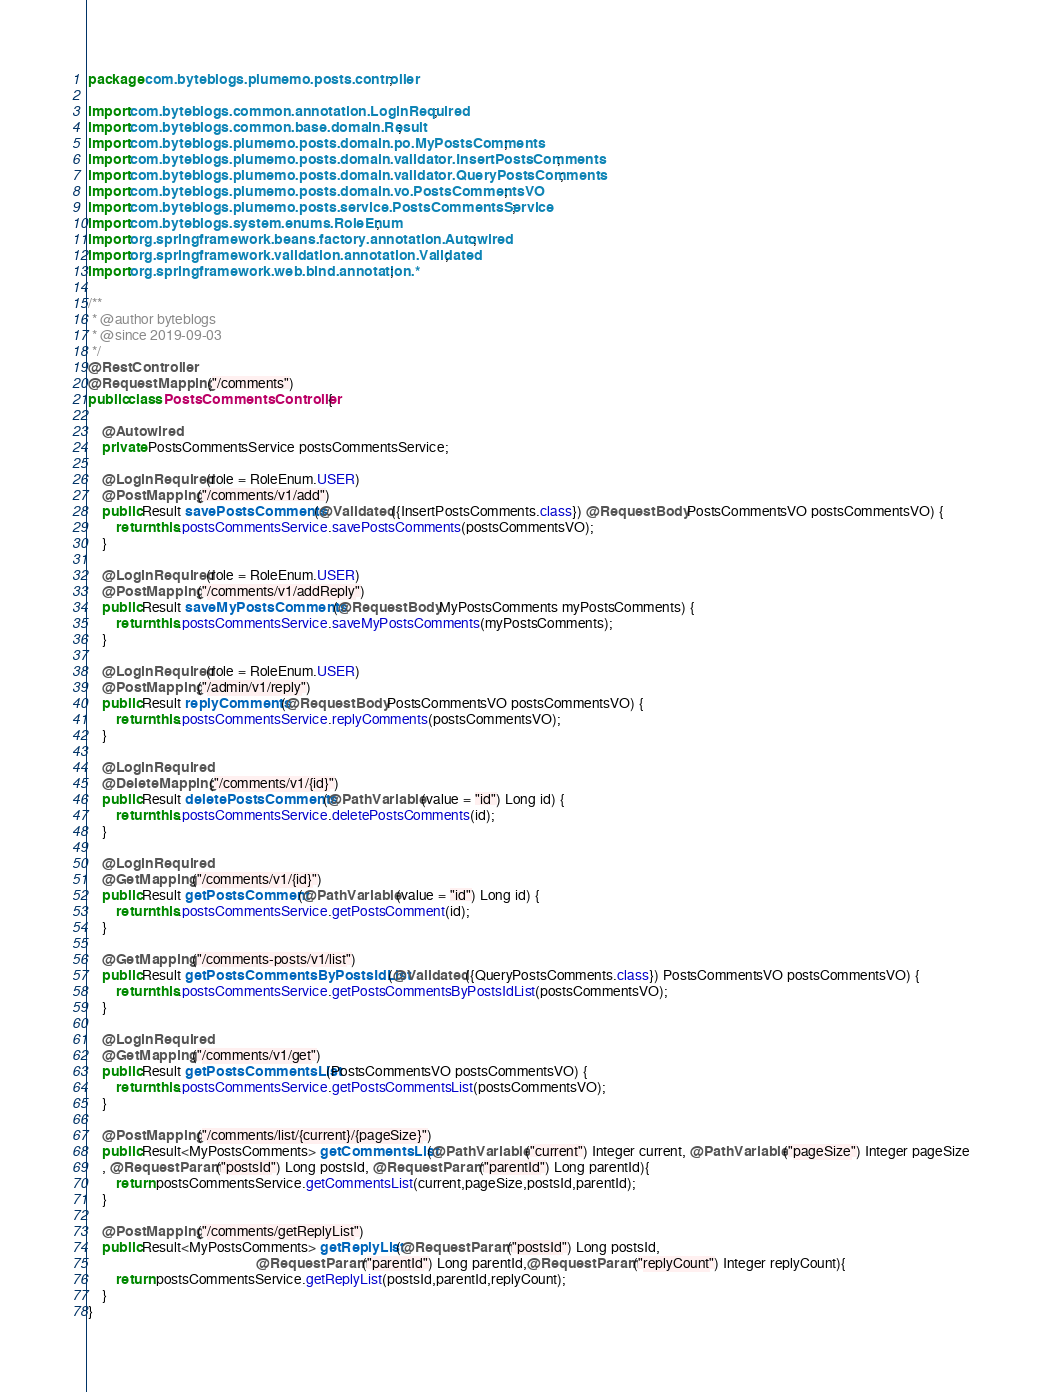Convert code to text. <code><loc_0><loc_0><loc_500><loc_500><_Java_>package com.byteblogs.plumemo.posts.controller;

import com.byteblogs.common.annotation.LoginRequired;
import com.byteblogs.common.base.domain.Result;
import com.byteblogs.plumemo.posts.domain.po.MyPostsComments;
import com.byteblogs.plumemo.posts.domain.validator.InsertPostsComments;
import com.byteblogs.plumemo.posts.domain.validator.QueryPostsComments;
import com.byteblogs.plumemo.posts.domain.vo.PostsCommentsVO;
import com.byteblogs.plumemo.posts.service.PostsCommentsService;
import com.byteblogs.system.enums.RoleEnum;
import org.springframework.beans.factory.annotation.Autowired;
import org.springframework.validation.annotation.Validated;
import org.springframework.web.bind.annotation.*;

/**
 * @author byteblogs
 * @since 2019-09-03
 */
@RestController
@RequestMapping("/comments")
public class PostsCommentsController {

    @Autowired
    private PostsCommentsService postsCommentsService;

    @LoginRequired(role = RoleEnum.USER)
    @PostMapping("/comments/v1/add")
    public Result savePostsComments(@Validated({InsertPostsComments.class}) @RequestBody PostsCommentsVO postsCommentsVO) {
        return this.postsCommentsService.savePostsComments(postsCommentsVO);
    }

    @LoginRequired(role = RoleEnum.USER)
    @PostMapping("/comments/v1/addReply")
    public Result saveMyPostsComments(@RequestBody MyPostsComments myPostsComments) {
        return this.postsCommentsService.saveMyPostsComments(myPostsComments);
    }

    @LoginRequired(role = RoleEnum.USER)
    @PostMapping("/admin/v1/reply")
    public Result replyComments(@RequestBody PostsCommentsVO postsCommentsVO) {
        return this.postsCommentsService.replyComments(postsCommentsVO);
    }

    @LoginRequired
    @DeleteMapping("/comments/v1/{id}")
    public Result deletePostsComments(@PathVariable(value = "id") Long id) {
        return this.postsCommentsService.deletePostsComments(id);
    }

    @LoginRequired
    @GetMapping("/comments/v1/{id}")
    public Result getPostsComment(@PathVariable(value = "id") Long id) {
        return this.postsCommentsService.getPostsComment(id);
    }

    @GetMapping("/comments-posts/v1/list")
    public Result getPostsCommentsByPostsIdList(@Validated({QueryPostsComments.class}) PostsCommentsVO postsCommentsVO) {
        return this.postsCommentsService.getPostsCommentsByPostsIdList(postsCommentsVO);
    }

    @LoginRequired
    @GetMapping("/comments/v1/get")
    public Result getPostsCommentsList(PostsCommentsVO postsCommentsVO) {
        return this.postsCommentsService.getPostsCommentsList(postsCommentsVO);
    }

    @PostMapping("/comments/list/{current}/{pageSize}")
    public Result<MyPostsComments> getCommentsList(@PathVariable("current") Integer current, @PathVariable("pageSize") Integer pageSize
    , @RequestParam("postsId") Long postsId, @RequestParam("parentId") Long parentId){
        return postsCommentsService.getCommentsList(current,pageSize,postsId,parentId);
    }

    @PostMapping("/comments/getReplyList")
    public Result<MyPostsComments> getReplyList(@RequestParam("postsId") Long postsId,
                                                @RequestParam("parentId") Long parentId,@RequestParam("replyCount") Integer replyCount){
        return postsCommentsService.getReplyList(postsId,parentId,replyCount);
    }
}
</code> 